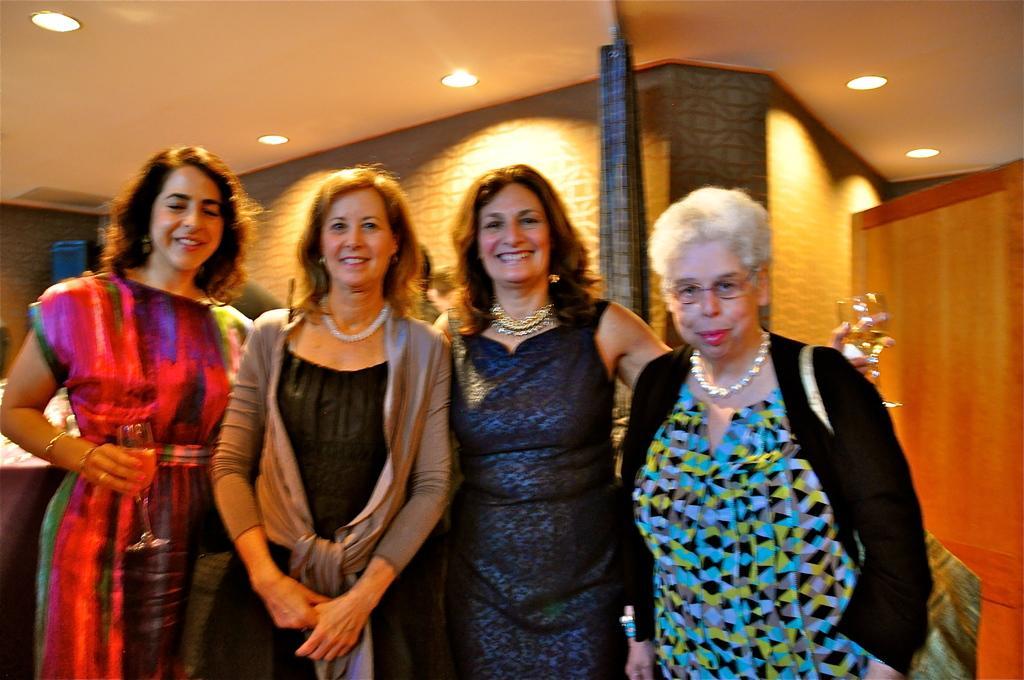Can you describe this image briefly? In this image, we can see some women standing and they are smiling, in the background there is a curtain and there are some lights at the top. 